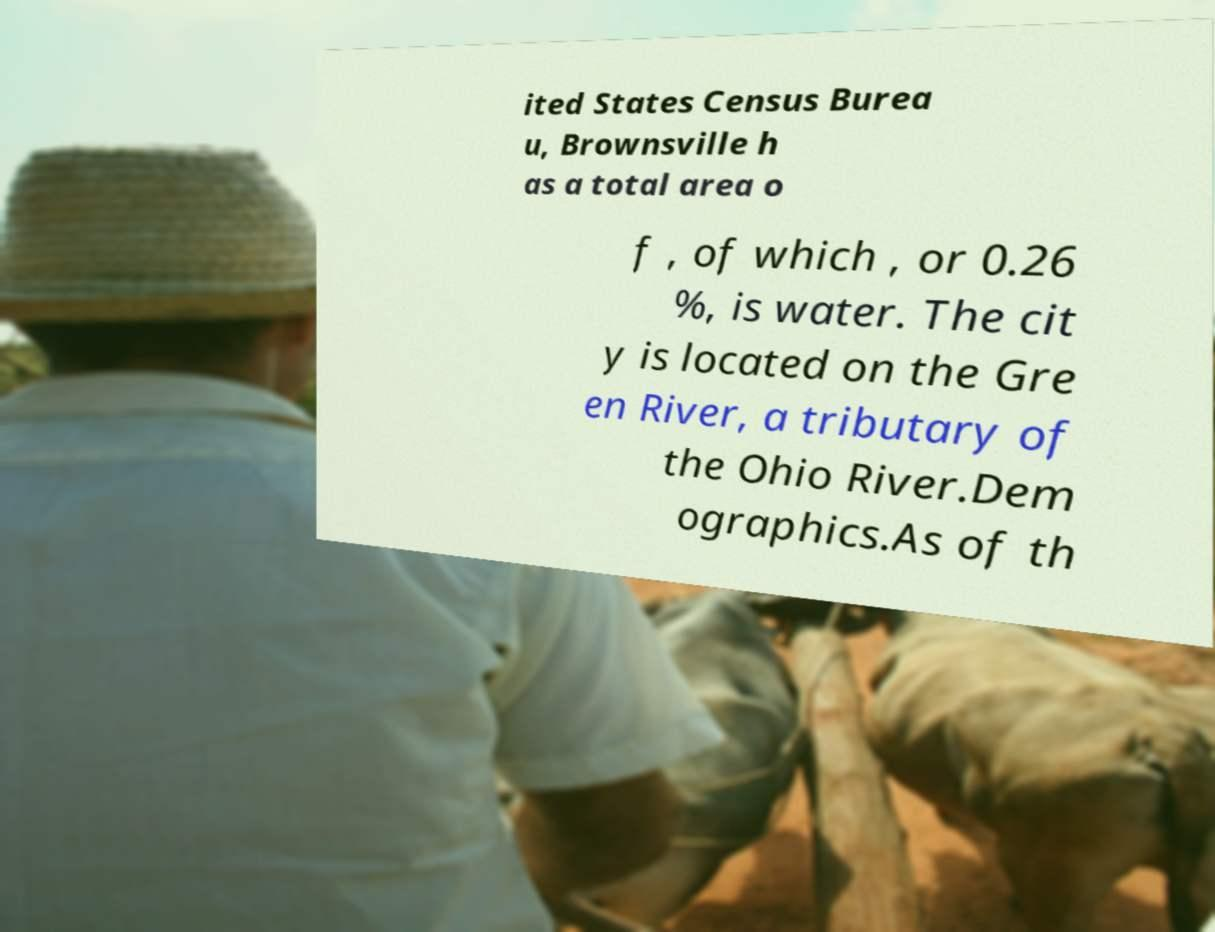There's text embedded in this image that I need extracted. Can you transcribe it verbatim? ited States Census Burea u, Brownsville h as a total area o f , of which , or 0.26 %, is water. The cit y is located on the Gre en River, a tributary of the Ohio River.Dem ographics.As of th 